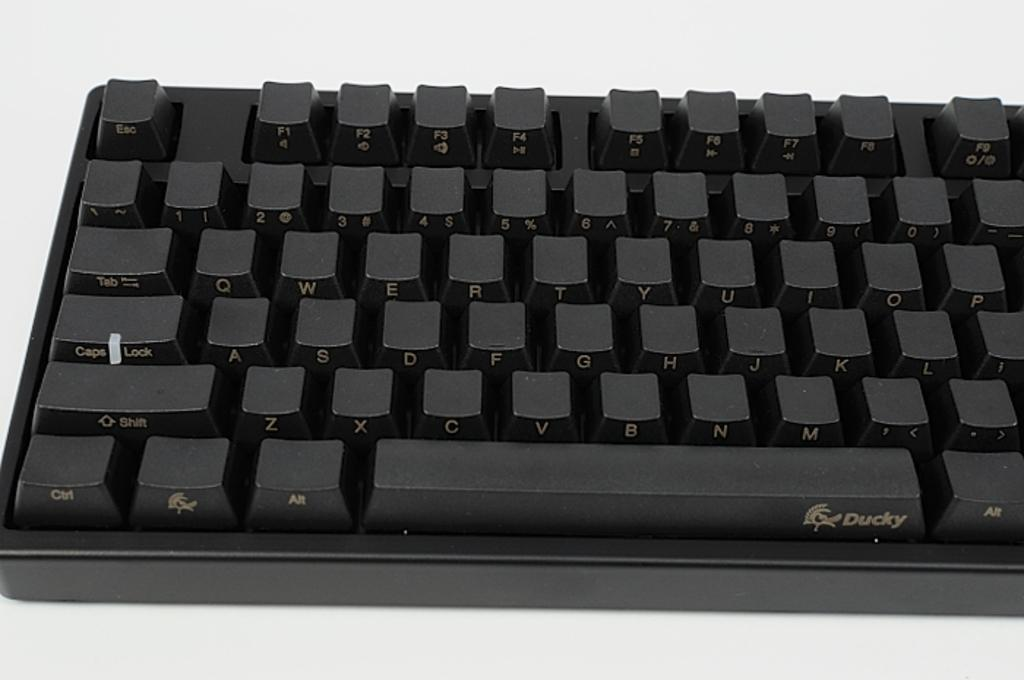<image>
Offer a succinct explanation of the picture presented. A ducky branded keyboard has black keys and letters on the side. 